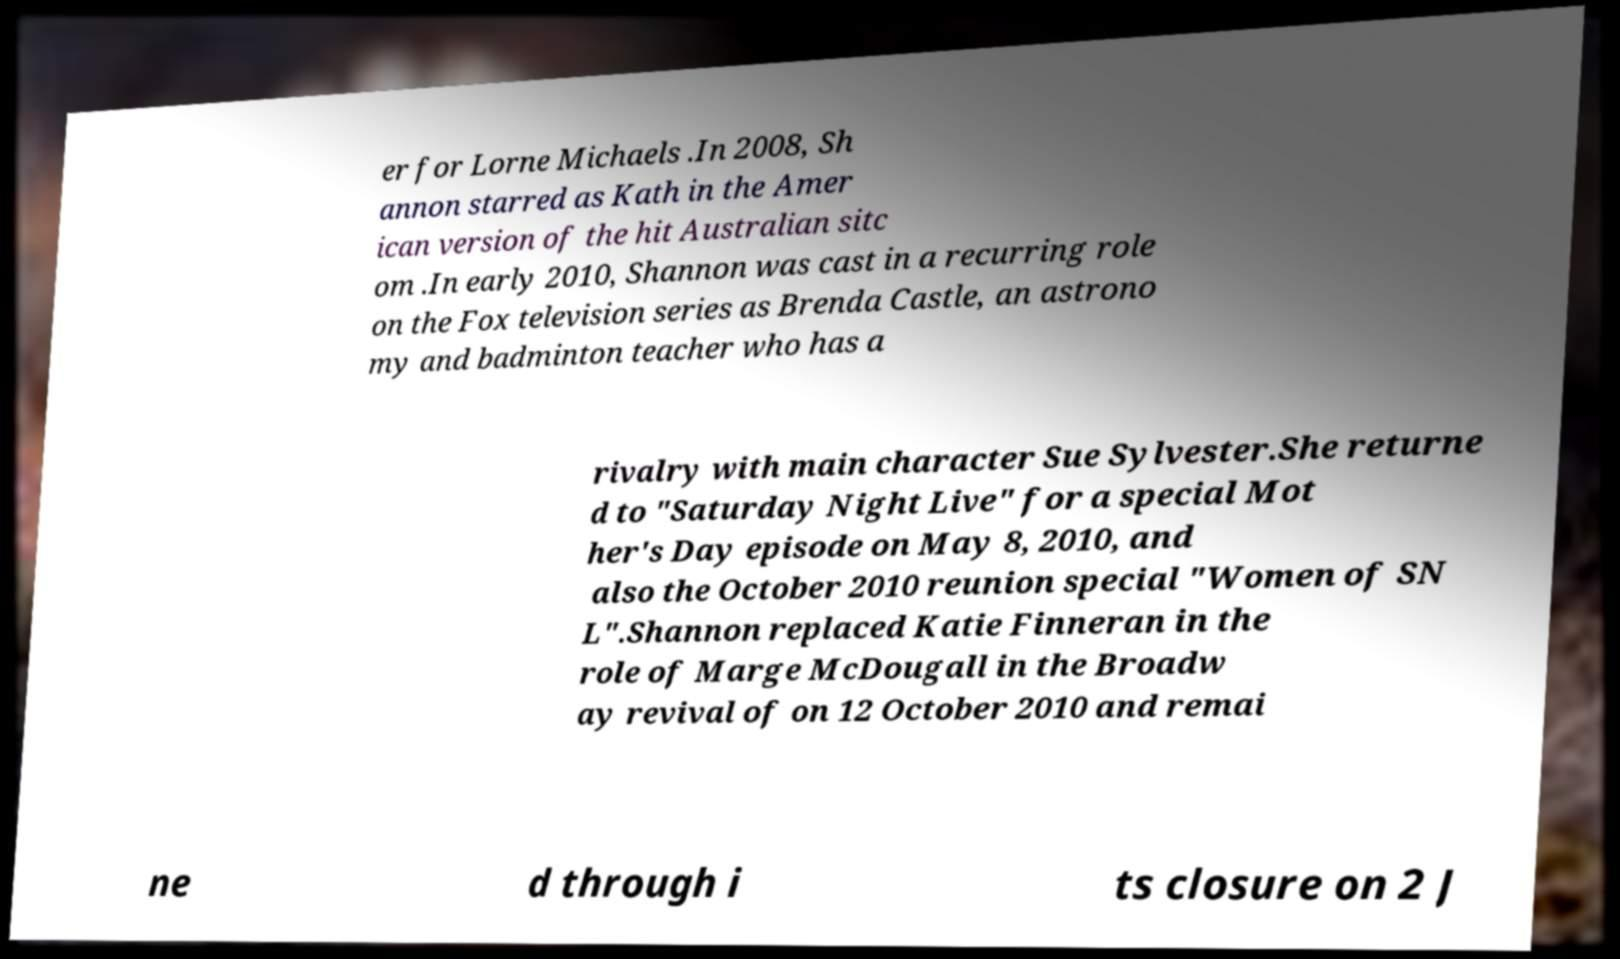Please read and relay the text visible in this image. What does it say? er for Lorne Michaels .In 2008, Sh annon starred as Kath in the Amer ican version of the hit Australian sitc om .In early 2010, Shannon was cast in a recurring role on the Fox television series as Brenda Castle, an astrono my and badminton teacher who has a rivalry with main character Sue Sylvester.She returne d to "Saturday Night Live" for a special Mot her's Day episode on May 8, 2010, and also the October 2010 reunion special "Women of SN L".Shannon replaced Katie Finneran in the role of Marge McDougall in the Broadw ay revival of on 12 October 2010 and remai ne d through i ts closure on 2 J 